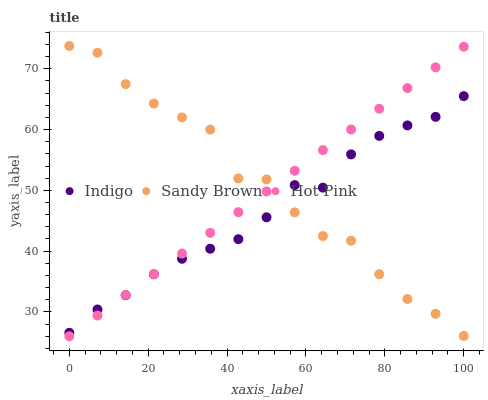Does Indigo have the minimum area under the curve?
Answer yes or no. Yes. Does Sandy Brown have the maximum area under the curve?
Answer yes or no. Yes. Does Hot Pink have the minimum area under the curve?
Answer yes or no. No. Does Hot Pink have the maximum area under the curve?
Answer yes or no. No. Is Hot Pink the smoothest?
Answer yes or no. Yes. Is Sandy Brown the roughest?
Answer yes or no. Yes. Is Indigo the smoothest?
Answer yes or no. No. Is Indigo the roughest?
Answer yes or no. No. Does Hot Pink have the lowest value?
Answer yes or no. Yes. Does Indigo have the lowest value?
Answer yes or no. No. Does Sandy Brown have the highest value?
Answer yes or no. Yes. Does Hot Pink have the highest value?
Answer yes or no. No. Does Indigo intersect Sandy Brown?
Answer yes or no. Yes. Is Indigo less than Sandy Brown?
Answer yes or no. No. Is Indigo greater than Sandy Brown?
Answer yes or no. No. 